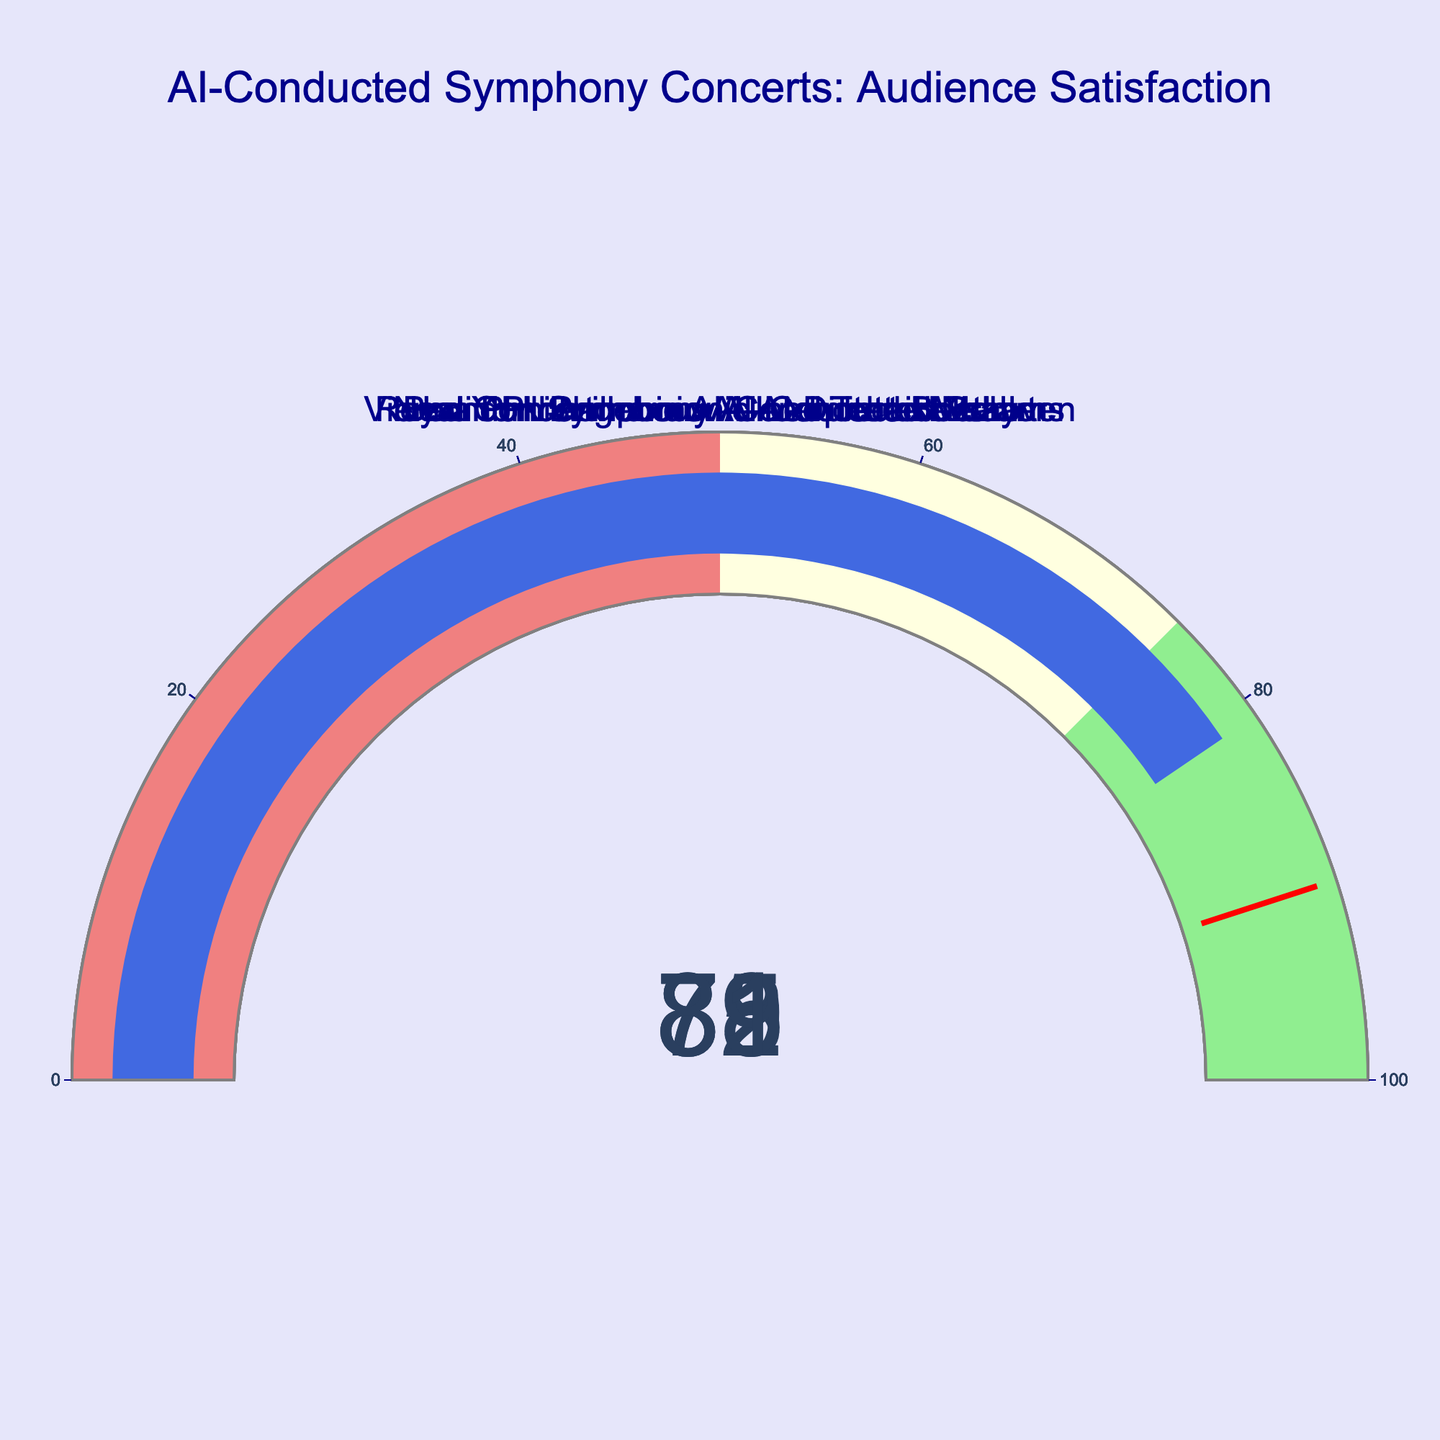What is the audience satisfaction for the Vienna Philharmonic AI-Conducted Beethoven concert? The concert name is shown as "Vienna Philharmonic AI-Conducted Beethoven" and the satisfaction percentage directly associated with it is visible as 85.
Answer: 85 What are the titles of the concerts displayed in the figure? By observing the figure, the titles of the concerts are displayed as labels on the gauges. They include: "Vienna Philharmonic AI-Conducted Beethoven," "Berlin Philharmonic AI-Interpreted Mozart," "London Symphony AI-Led Tchaikovsky," "New York Philharmonic AI-Directed Mahler," and "Royal Concertgebouw AI-Conducted Brahms."
Answer: Vienna Philharmonic AI-Conducted Beethoven, Berlin Philharmonic AI-Interpreted Mozart, London Symphony AI-Led Tchaikovsky, New York Philharmonic AI-Directed Mahler, Royal Concertgebouw AI-Conducted Brahms Which AI-conducted concert had the lowest audience satisfaction rating? Look at the satisfaction ratings on all the gauges and identify the lowest number. The satisfaction ratings are 85, 78, 82, 79, and 81, with the lowest being 78 for the Berlin Philharmonic AI-Interpreted Mozart concert.
Answer: Berlin Philharmonic AI-Interpreted Mozart What is the range of satisfaction ratings displayed in the figure? Determine the smallest and largest percentages among the satisfaction ratings. The lowest rating is 78 and the highest is 85, hence the range is from 78 to 85.
Answer: 78 to 85 What is the average audience satisfaction rating across all five AI-conducted concerts? Add up each of the satisfaction ratings and divide by the number of concerts: (85 + 78 + 82 + 79 + 81) / 5. This calculates to 405/5 = 81.
Answer: 81 How many concerts fall into the 'lightgreen' satisfaction range (75-100)? Examine each gauge's satisfaction rating and count how many fall between 75 and 100. Satisfaction ratings of 85, 78, 82, 79, and 81 are all within this range.
Answer: 5 Which concert's satisfaction rating is the closest to the threshold of 90? Identify the satisfaction rating closest to 90 by comparing differences for each concert: 90 - 85, 90 - 78, 90 - 82, 90 - 79, and 90 - 81. The closest difference is 90 - 85 = 5.
Answer: Vienna Philharmonic AI-Conducted Beethoven How does the satisfaction for the New York Philharmonic AI-Directed Mahler compare to the London Symphony AI-Led Tchaikovsky? Look at the satisfaction ratings: New York Philharmonic AI-Directed Mahler has a rating of 79, while London Symphony AI-Led Tchaikovsky has a rating of 82. Comparing these, we see that London's rating is 3 points higher than New York's.
Answer: London Symphony AI-Led Tchaikovsky is higher What is the difference in satisfaction between the highest and lowest rated concerts? Identify the highest and lowest satisfaction ratings, which are 85 and 78 respectively. The difference between these is calculated as 85 - 78.
Answer: 7 